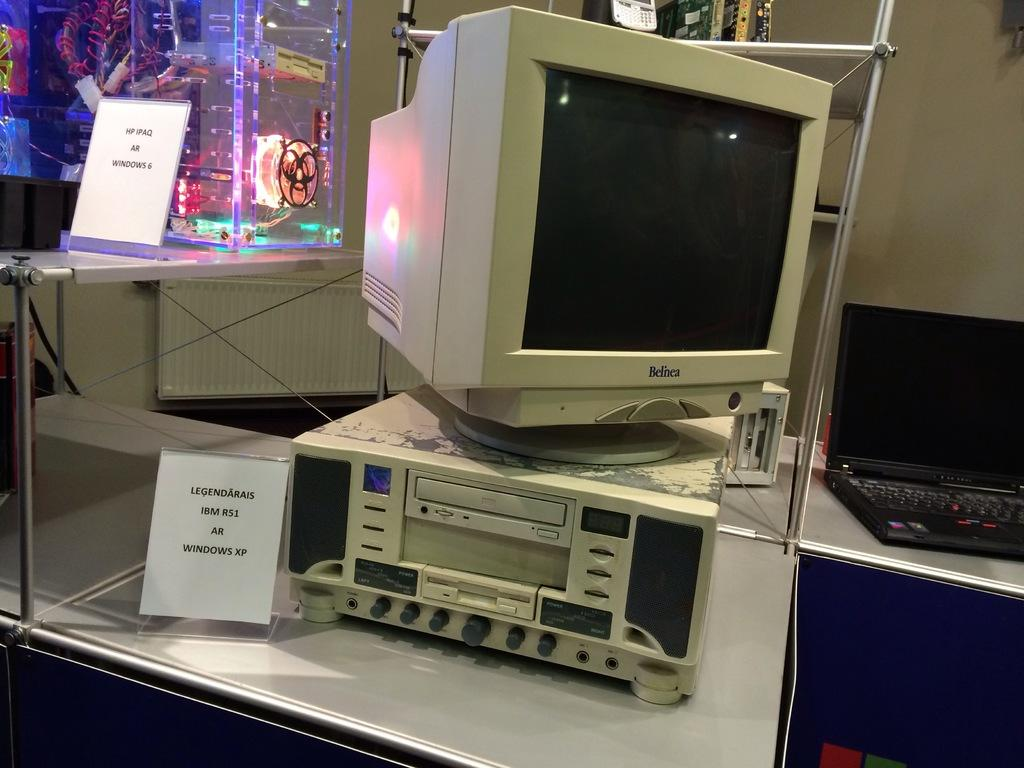<image>
Provide a brief description of the given image. The name on the screen of this computer is Belnea. 